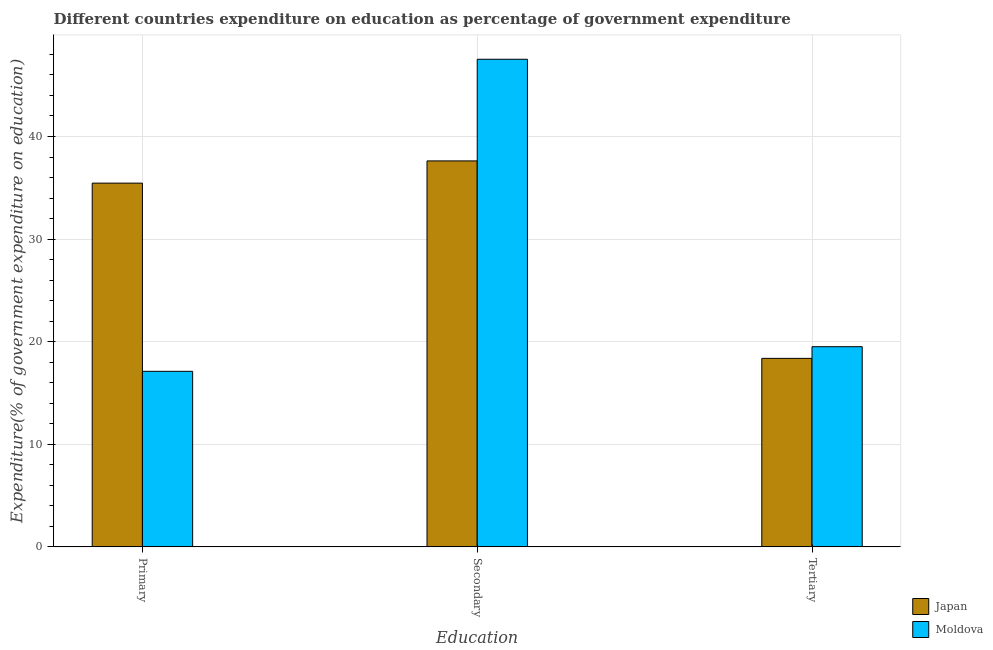How many different coloured bars are there?
Your response must be concise. 2. How many bars are there on the 3rd tick from the left?
Keep it short and to the point. 2. What is the label of the 3rd group of bars from the left?
Your answer should be compact. Tertiary. What is the expenditure on tertiary education in Japan?
Give a very brief answer. 18.37. Across all countries, what is the maximum expenditure on tertiary education?
Provide a short and direct response. 19.51. Across all countries, what is the minimum expenditure on tertiary education?
Make the answer very short. 18.37. In which country was the expenditure on tertiary education maximum?
Make the answer very short. Moldova. In which country was the expenditure on primary education minimum?
Offer a very short reply. Moldova. What is the total expenditure on tertiary education in the graph?
Make the answer very short. 37.88. What is the difference between the expenditure on tertiary education in Japan and that in Moldova?
Offer a very short reply. -1.14. What is the difference between the expenditure on tertiary education in Japan and the expenditure on primary education in Moldova?
Your response must be concise. 1.26. What is the average expenditure on tertiary education per country?
Provide a succinct answer. 18.94. What is the difference between the expenditure on tertiary education and expenditure on primary education in Japan?
Offer a very short reply. -17.08. In how many countries, is the expenditure on tertiary education greater than 40 %?
Keep it short and to the point. 0. What is the ratio of the expenditure on secondary education in Japan to that in Moldova?
Your response must be concise. 0.79. What is the difference between the highest and the second highest expenditure on primary education?
Provide a short and direct response. 18.34. What is the difference between the highest and the lowest expenditure on secondary education?
Make the answer very short. 9.91. In how many countries, is the expenditure on primary education greater than the average expenditure on primary education taken over all countries?
Your answer should be very brief. 1. Is the sum of the expenditure on primary education in Moldova and Japan greater than the maximum expenditure on tertiary education across all countries?
Your answer should be very brief. Yes. What does the 2nd bar from the left in Primary represents?
Offer a terse response. Moldova. How many countries are there in the graph?
Make the answer very short. 2. Does the graph contain grids?
Give a very brief answer. Yes. How are the legend labels stacked?
Your answer should be compact. Vertical. What is the title of the graph?
Your answer should be very brief. Different countries expenditure on education as percentage of government expenditure. Does "Senegal" appear as one of the legend labels in the graph?
Your response must be concise. No. What is the label or title of the X-axis?
Provide a short and direct response. Education. What is the label or title of the Y-axis?
Give a very brief answer. Expenditure(% of government expenditure on education). What is the Expenditure(% of government expenditure on education) in Japan in Primary?
Your answer should be compact. 35.45. What is the Expenditure(% of government expenditure on education) in Moldova in Primary?
Your response must be concise. 17.11. What is the Expenditure(% of government expenditure on education) in Japan in Secondary?
Your response must be concise. 37.62. What is the Expenditure(% of government expenditure on education) of Moldova in Secondary?
Give a very brief answer. 47.53. What is the Expenditure(% of government expenditure on education) of Japan in Tertiary?
Provide a short and direct response. 18.37. What is the Expenditure(% of government expenditure on education) of Moldova in Tertiary?
Give a very brief answer. 19.51. Across all Education, what is the maximum Expenditure(% of government expenditure on education) of Japan?
Give a very brief answer. 37.62. Across all Education, what is the maximum Expenditure(% of government expenditure on education) in Moldova?
Provide a short and direct response. 47.53. Across all Education, what is the minimum Expenditure(% of government expenditure on education) of Japan?
Keep it short and to the point. 18.37. Across all Education, what is the minimum Expenditure(% of government expenditure on education) in Moldova?
Your response must be concise. 17.11. What is the total Expenditure(% of government expenditure on education) in Japan in the graph?
Make the answer very short. 91.45. What is the total Expenditure(% of government expenditure on education) in Moldova in the graph?
Provide a short and direct response. 84.15. What is the difference between the Expenditure(% of government expenditure on education) of Japan in Primary and that in Secondary?
Your answer should be compact. -2.17. What is the difference between the Expenditure(% of government expenditure on education) of Moldova in Primary and that in Secondary?
Your answer should be compact. -30.42. What is the difference between the Expenditure(% of government expenditure on education) of Japan in Primary and that in Tertiary?
Give a very brief answer. 17.08. What is the difference between the Expenditure(% of government expenditure on education) in Moldova in Primary and that in Tertiary?
Your answer should be compact. -2.4. What is the difference between the Expenditure(% of government expenditure on education) of Japan in Secondary and that in Tertiary?
Your answer should be compact. 19.25. What is the difference between the Expenditure(% of government expenditure on education) of Moldova in Secondary and that in Tertiary?
Your response must be concise. 28.02. What is the difference between the Expenditure(% of government expenditure on education) in Japan in Primary and the Expenditure(% of government expenditure on education) in Moldova in Secondary?
Keep it short and to the point. -12.08. What is the difference between the Expenditure(% of government expenditure on education) of Japan in Primary and the Expenditure(% of government expenditure on education) of Moldova in Tertiary?
Your answer should be very brief. 15.94. What is the difference between the Expenditure(% of government expenditure on education) of Japan in Secondary and the Expenditure(% of government expenditure on education) of Moldova in Tertiary?
Keep it short and to the point. 18.11. What is the average Expenditure(% of government expenditure on education) in Japan per Education?
Provide a succinct answer. 30.48. What is the average Expenditure(% of government expenditure on education) of Moldova per Education?
Your answer should be compact. 28.05. What is the difference between the Expenditure(% of government expenditure on education) of Japan and Expenditure(% of government expenditure on education) of Moldova in Primary?
Your answer should be compact. 18.34. What is the difference between the Expenditure(% of government expenditure on education) in Japan and Expenditure(% of government expenditure on education) in Moldova in Secondary?
Provide a short and direct response. -9.91. What is the difference between the Expenditure(% of government expenditure on education) of Japan and Expenditure(% of government expenditure on education) of Moldova in Tertiary?
Give a very brief answer. -1.14. What is the ratio of the Expenditure(% of government expenditure on education) in Japan in Primary to that in Secondary?
Your answer should be very brief. 0.94. What is the ratio of the Expenditure(% of government expenditure on education) in Moldova in Primary to that in Secondary?
Your answer should be very brief. 0.36. What is the ratio of the Expenditure(% of government expenditure on education) of Japan in Primary to that in Tertiary?
Make the answer very short. 1.93. What is the ratio of the Expenditure(% of government expenditure on education) in Moldova in Primary to that in Tertiary?
Offer a terse response. 0.88. What is the ratio of the Expenditure(% of government expenditure on education) of Japan in Secondary to that in Tertiary?
Your answer should be compact. 2.05. What is the ratio of the Expenditure(% of government expenditure on education) in Moldova in Secondary to that in Tertiary?
Give a very brief answer. 2.44. What is the difference between the highest and the second highest Expenditure(% of government expenditure on education) in Japan?
Keep it short and to the point. 2.17. What is the difference between the highest and the second highest Expenditure(% of government expenditure on education) in Moldova?
Provide a succinct answer. 28.02. What is the difference between the highest and the lowest Expenditure(% of government expenditure on education) in Japan?
Your answer should be compact. 19.25. What is the difference between the highest and the lowest Expenditure(% of government expenditure on education) of Moldova?
Your answer should be very brief. 30.42. 